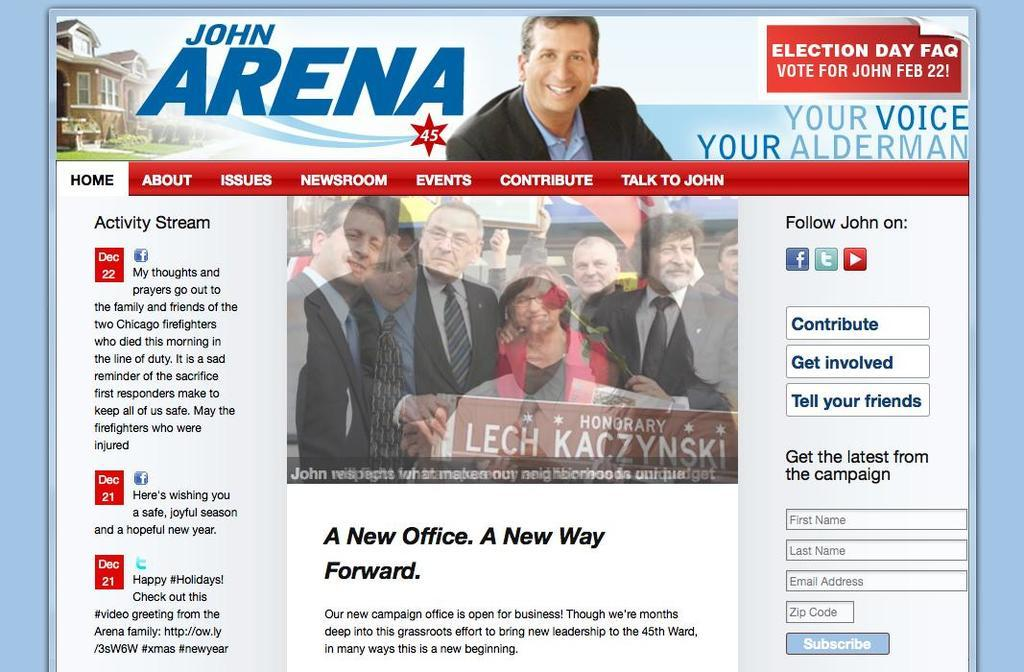What type of image is being described? The image is a digital page. Can you describe the man in the image? The man in the image is smiling and wearing a coat. Are there any other people in the image besides the man? Yes, there are other people in the image. How many children are holding the man's arm in the image? There are no children present in the image, and the man's arm is not being held by anyone. 